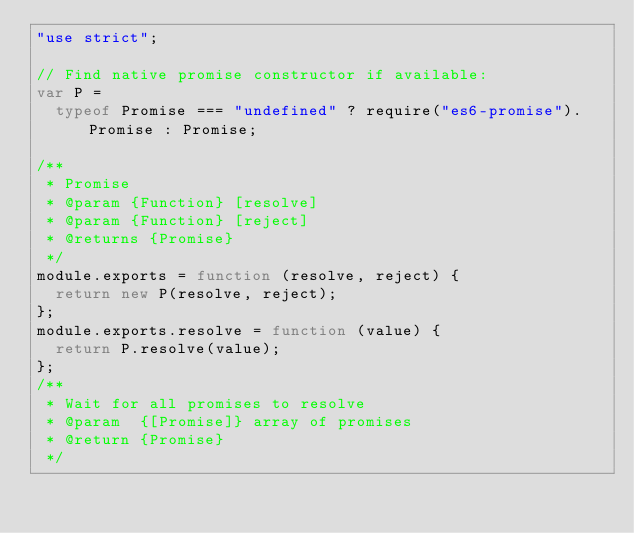<code> <loc_0><loc_0><loc_500><loc_500><_JavaScript_>"use strict";

// Find native promise constructor if available:
var P =
  typeof Promise === "undefined" ? require("es6-promise").Promise : Promise;

/**
 * Promise
 * @param {Function} [resolve]
 * @param {Function} [reject]
 * @returns {Promise}
 */
module.exports = function (resolve, reject) {
  return new P(resolve, reject);
};
module.exports.resolve = function (value) {
  return P.resolve(value);
};
/**
 * Wait for all promises to resolve
 * @param  {[Promise]} array of promises
 * @return {Promise}
 */</code> 